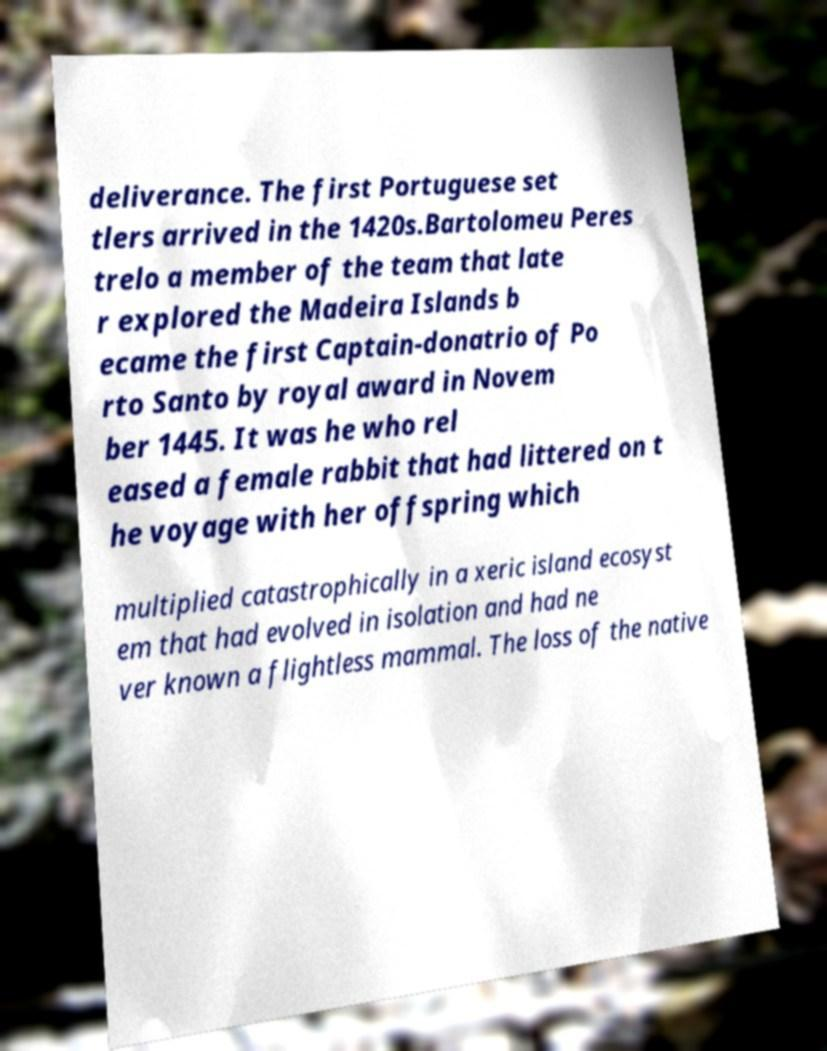Can you accurately transcribe the text from the provided image for me? deliverance. The first Portuguese set tlers arrived in the 1420s.Bartolomeu Peres trelo a member of the team that late r explored the Madeira Islands b ecame the first Captain-donatrio of Po rto Santo by royal award in Novem ber 1445. It was he who rel eased a female rabbit that had littered on t he voyage with her offspring which multiplied catastrophically in a xeric island ecosyst em that had evolved in isolation and had ne ver known a flightless mammal. The loss of the native 